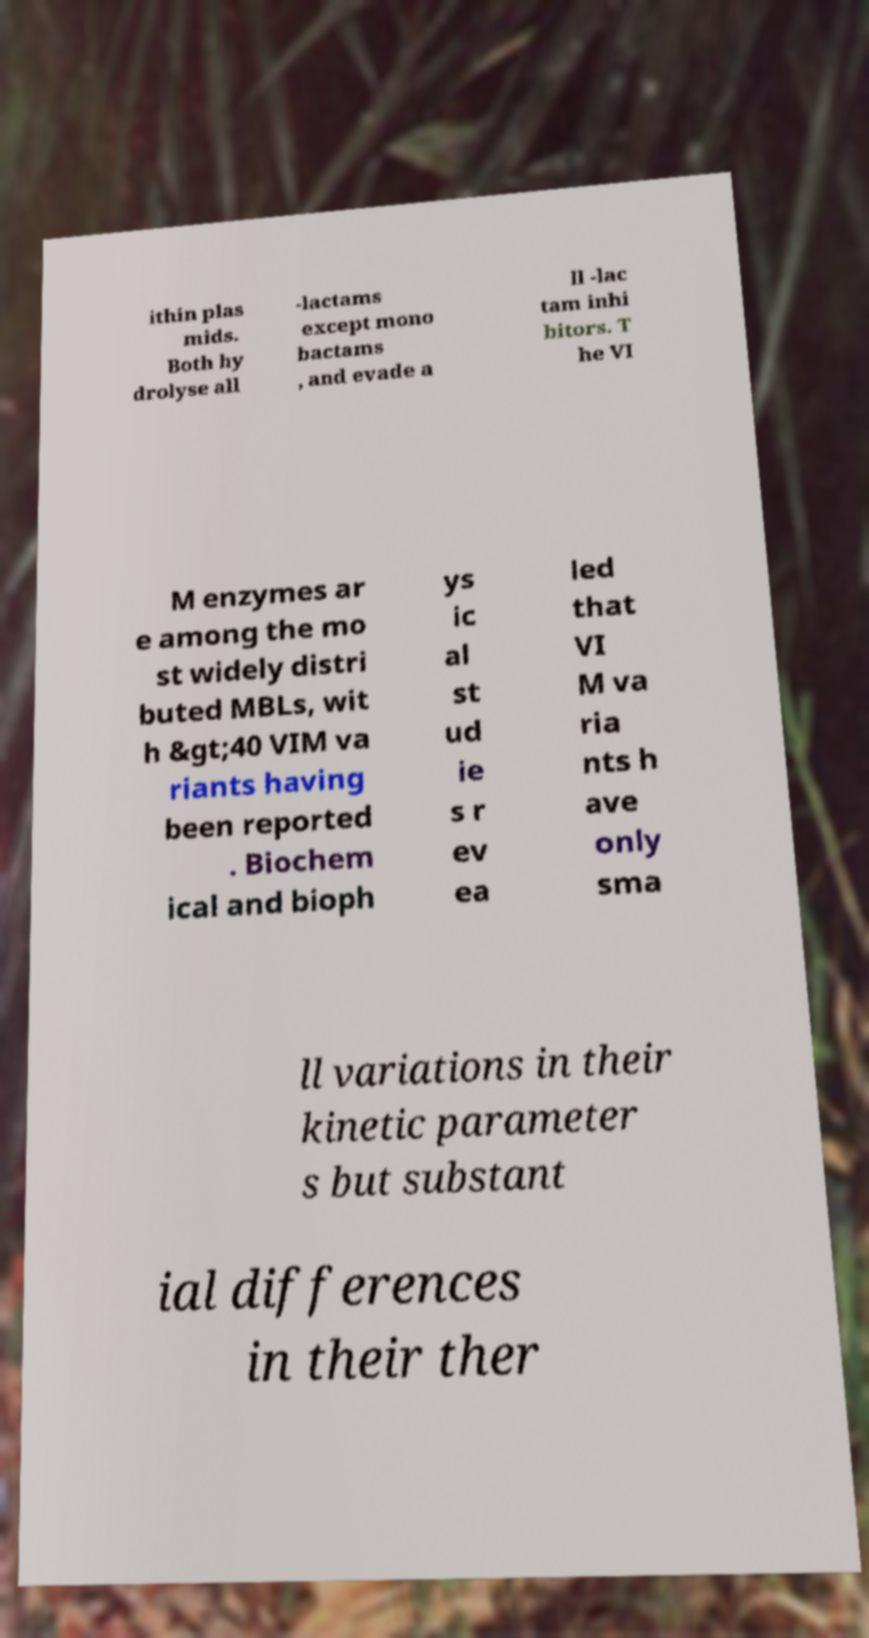Could you extract and type out the text from this image? ithin plas mids. Both hy drolyse all -lactams except mono bactams , and evade a ll -lac tam inhi bitors. T he VI M enzymes ar e among the mo st widely distri buted MBLs, wit h &gt;40 VIM va riants having been reported . Biochem ical and bioph ys ic al st ud ie s r ev ea led that VI M va ria nts h ave only sma ll variations in their kinetic parameter s but substant ial differences in their ther 